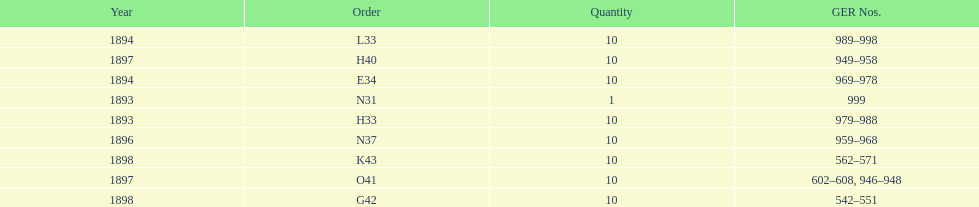What is the number of years with a quantity of 10? 5. 